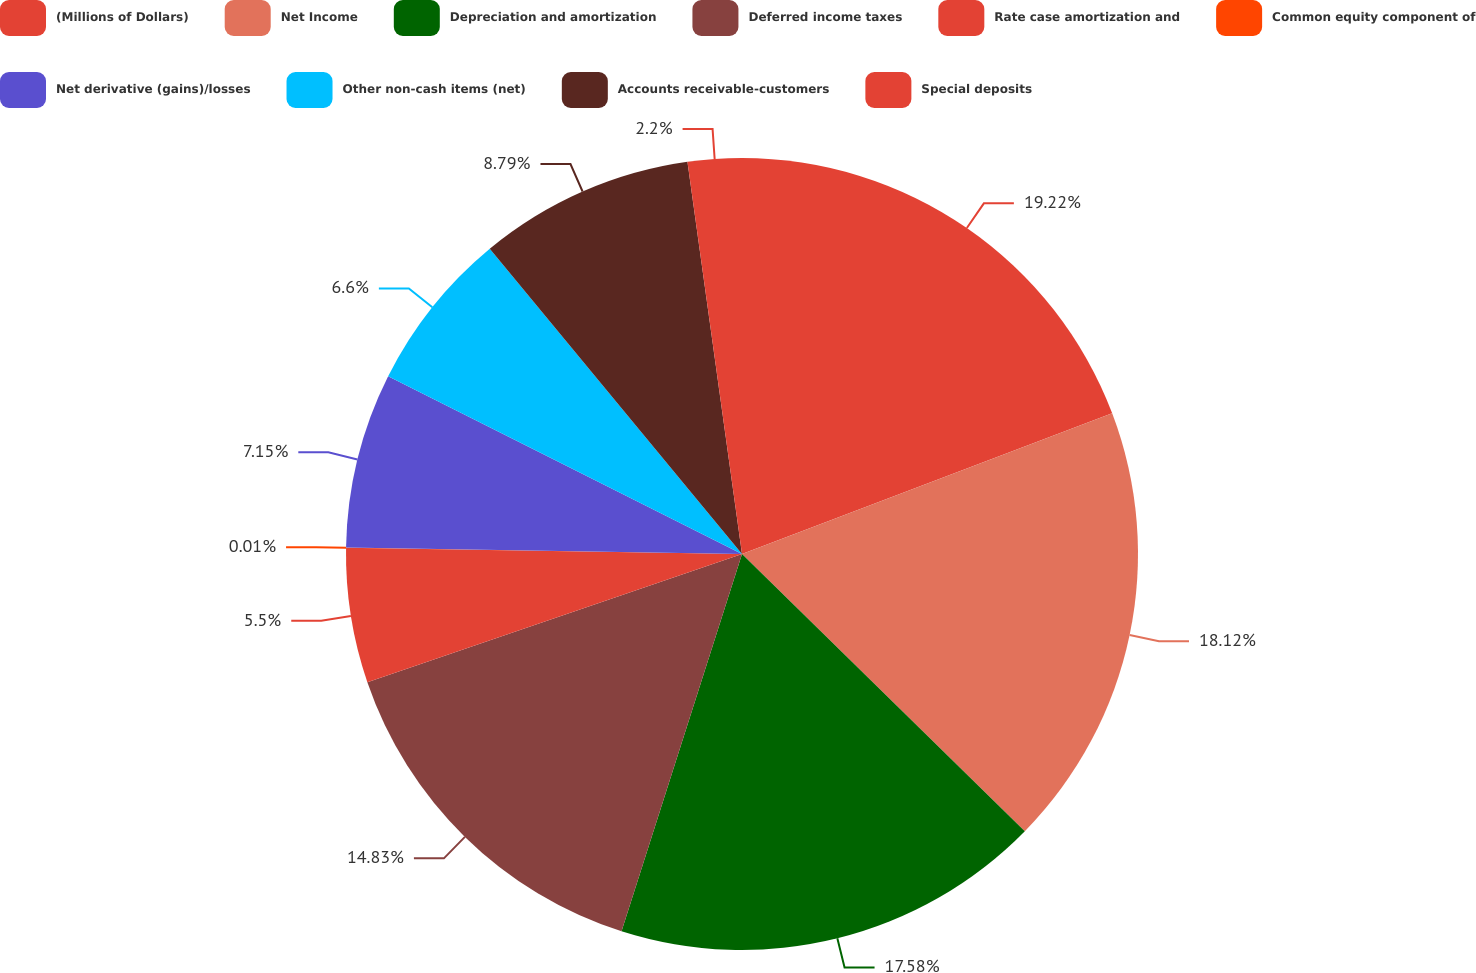Convert chart. <chart><loc_0><loc_0><loc_500><loc_500><pie_chart><fcel>(Millions of Dollars)<fcel>Net Income<fcel>Depreciation and amortization<fcel>Deferred income taxes<fcel>Rate case amortization and<fcel>Common equity component of<fcel>Net derivative (gains)/losses<fcel>Other non-cash items (net)<fcel>Accounts receivable-customers<fcel>Special deposits<nl><fcel>19.22%<fcel>18.12%<fcel>17.58%<fcel>14.83%<fcel>5.5%<fcel>0.01%<fcel>7.15%<fcel>6.6%<fcel>8.79%<fcel>2.2%<nl></chart> 